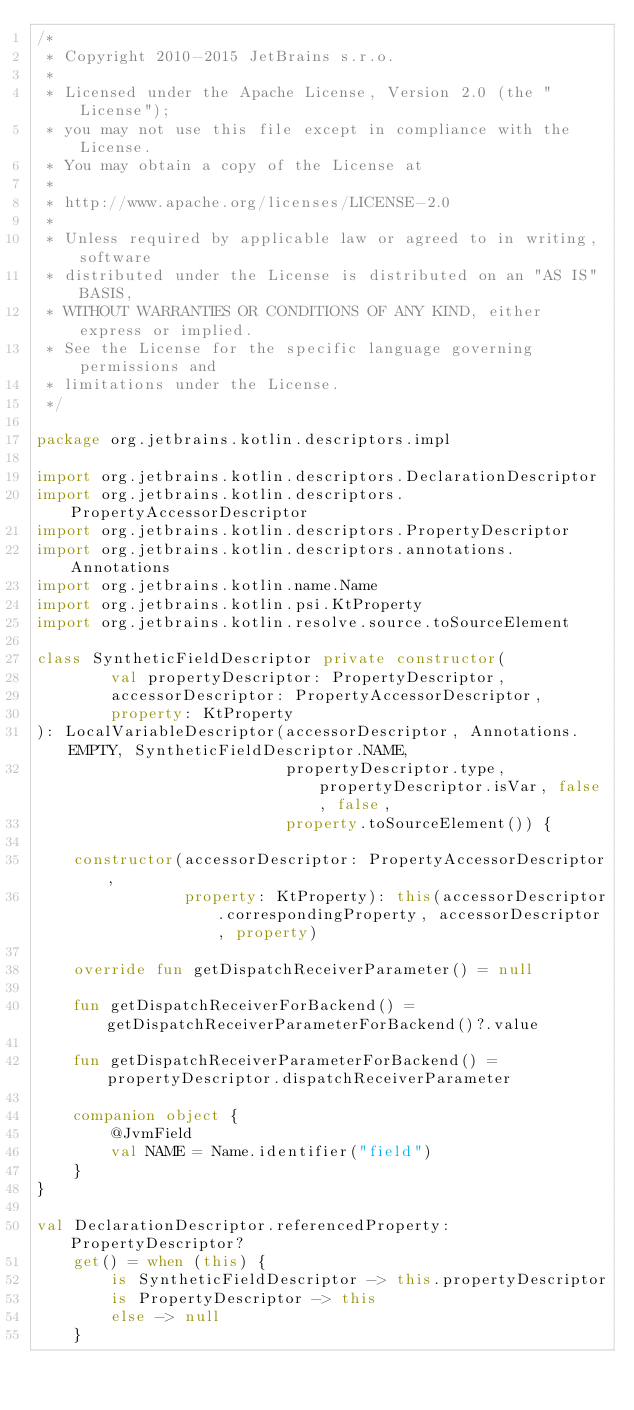Convert code to text. <code><loc_0><loc_0><loc_500><loc_500><_Kotlin_>/*
 * Copyright 2010-2015 JetBrains s.r.o.
 *
 * Licensed under the Apache License, Version 2.0 (the "License");
 * you may not use this file except in compliance with the License.
 * You may obtain a copy of the License at
 *
 * http://www.apache.org/licenses/LICENSE-2.0
 *
 * Unless required by applicable law or agreed to in writing, software
 * distributed under the License is distributed on an "AS IS" BASIS,
 * WITHOUT WARRANTIES OR CONDITIONS OF ANY KIND, either express or implied.
 * See the License for the specific language governing permissions and
 * limitations under the License.
 */

package org.jetbrains.kotlin.descriptors.impl

import org.jetbrains.kotlin.descriptors.DeclarationDescriptor
import org.jetbrains.kotlin.descriptors.PropertyAccessorDescriptor
import org.jetbrains.kotlin.descriptors.PropertyDescriptor
import org.jetbrains.kotlin.descriptors.annotations.Annotations
import org.jetbrains.kotlin.name.Name
import org.jetbrains.kotlin.psi.KtProperty
import org.jetbrains.kotlin.resolve.source.toSourceElement

class SyntheticFieldDescriptor private constructor(
        val propertyDescriptor: PropertyDescriptor,
        accessorDescriptor: PropertyAccessorDescriptor,
        property: KtProperty
): LocalVariableDescriptor(accessorDescriptor, Annotations.EMPTY, SyntheticFieldDescriptor.NAME,
                           propertyDescriptor.type, propertyDescriptor.isVar, false, false,
                           property.toSourceElement()) {

    constructor(accessorDescriptor: PropertyAccessorDescriptor,
                property: KtProperty): this(accessorDescriptor.correspondingProperty, accessorDescriptor, property)

    override fun getDispatchReceiverParameter() = null

    fun getDispatchReceiverForBackend() = getDispatchReceiverParameterForBackend()?.value

    fun getDispatchReceiverParameterForBackend() = propertyDescriptor.dispatchReceiverParameter

    companion object {
        @JvmField
        val NAME = Name.identifier("field")
    }
}

val DeclarationDescriptor.referencedProperty: PropertyDescriptor?
    get() = when (this) {
        is SyntheticFieldDescriptor -> this.propertyDescriptor
        is PropertyDescriptor -> this
        else -> null
    }
</code> 